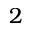<formula> <loc_0><loc_0><loc_500><loc_500>2</formula> 